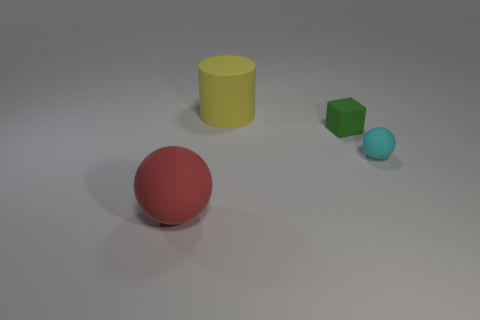Add 1 large rubber balls. How many objects exist? 5 Subtract all cyan balls. How many balls are left? 1 Add 2 large yellow things. How many large yellow things exist? 3 Subtract 1 green cubes. How many objects are left? 3 Subtract all cylinders. How many objects are left? 3 Subtract 1 blocks. How many blocks are left? 0 Subtract all brown balls. Subtract all cyan cylinders. How many balls are left? 2 Subtract all yellow rubber cylinders. Subtract all yellow matte objects. How many objects are left? 2 Add 4 yellow cylinders. How many yellow cylinders are left? 5 